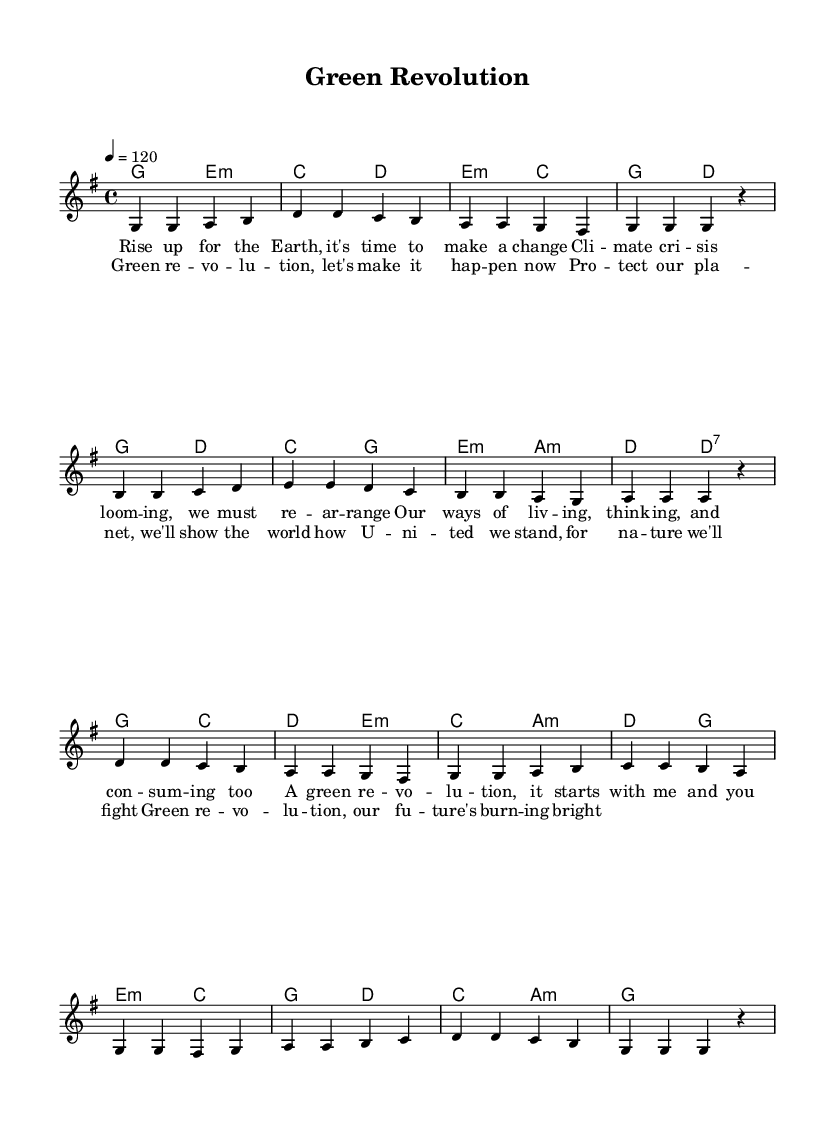What is the key signature of this music? The key signature is G major, which has one sharp (F#). This is indicated at the beginning of the staff.
Answer: G major What is the time signature of this music? The time signature is 4/4, as shown at the beginning of the score. This means there are four beats in each measure and a quarter note receives one beat.
Answer: 4/4 What is the tempo indicated for the piece? The tempo is marked as "4 = 120," indicating that the quarter note should be played at a speed of 120 beats per minute.
Answer: 120 How many measures are in the chorus? By counting the individual measures in the provided section marked by the chorus lyrics, there are 4 measures.
Answer: 4 What is the mood suggested by the lyrics in this piece? The lyrics suggest a hopeful and proactive mood about environmental activism and change, emphasizing unity and a positive future.
Answer: hopeful Identify the first word of the chorus. The first word of the chorus section is "Green," as indicated at the start of the lyrics.
Answer: Green What type of harmony is predominantly used in the piece? The harmonies mainly consist of triads, typically found in popular music, indicating a simple and catchy harmonic structure.
Answer: triads 